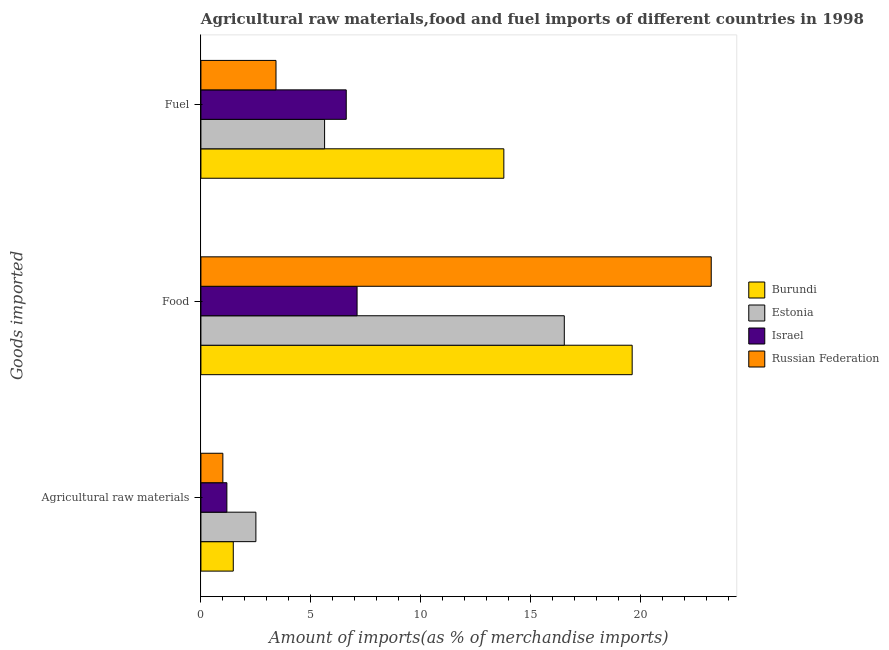How many different coloured bars are there?
Your response must be concise. 4. How many groups of bars are there?
Your response must be concise. 3. What is the label of the 3rd group of bars from the top?
Ensure brevity in your answer.  Agricultural raw materials. What is the percentage of food imports in Russian Federation?
Give a very brief answer. 23.2. Across all countries, what is the maximum percentage of food imports?
Provide a succinct answer. 23.2. Across all countries, what is the minimum percentage of food imports?
Provide a short and direct response. 7.1. In which country was the percentage of food imports maximum?
Offer a terse response. Russian Federation. In which country was the percentage of raw materials imports minimum?
Ensure brevity in your answer.  Russian Federation. What is the total percentage of fuel imports in the graph?
Your response must be concise. 29.41. What is the difference between the percentage of raw materials imports in Burundi and that in Estonia?
Your answer should be compact. -1.03. What is the difference between the percentage of raw materials imports in Israel and the percentage of food imports in Russian Federation?
Your answer should be compact. -22.02. What is the average percentage of fuel imports per country?
Make the answer very short. 7.35. What is the difference between the percentage of food imports and percentage of fuel imports in Russian Federation?
Keep it short and to the point. 19.78. What is the ratio of the percentage of fuel imports in Estonia to that in Russian Federation?
Your response must be concise. 1.65. Is the difference between the percentage of raw materials imports in Estonia and Russian Federation greater than the difference between the percentage of fuel imports in Estonia and Russian Federation?
Make the answer very short. No. What is the difference between the highest and the second highest percentage of raw materials imports?
Provide a succinct answer. 1.03. What is the difference between the highest and the lowest percentage of food imports?
Provide a succinct answer. 16.1. Is the sum of the percentage of food imports in Russian Federation and Burundi greater than the maximum percentage of raw materials imports across all countries?
Provide a succinct answer. Yes. What does the 4th bar from the top in Agricultural raw materials represents?
Ensure brevity in your answer.  Burundi. What does the 4th bar from the bottom in Agricultural raw materials represents?
Provide a short and direct response. Russian Federation. How many bars are there?
Provide a short and direct response. 12. What is the difference between two consecutive major ticks on the X-axis?
Your answer should be very brief. 5. Does the graph contain any zero values?
Offer a very short reply. No. How many legend labels are there?
Ensure brevity in your answer.  4. How are the legend labels stacked?
Provide a succinct answer. Vertical. What is the title of the graph?
Keep it short and to the point. Agricultural raw materials,food and fuel imports of different countries in 1998. Does "High income: OECD" appear as one of the legend labels in the graph?
Keep it short and to the point. No. What is the label or title of the X-axis?
Give a very brief answer. Amount of imports(as % of merchandise imports). What is the label or title of the Y-axis?
Make the answer very short. Goods imported. What is the Amount of imports(as % of merchandise imports) in Burundi in Agricultural raw materials?
Offer a very short reply. 1.47. What is the Amount of imports(as % of merchandise imports) of Estonia in Agricultural raw materials?
Offer a terse response. 2.5. What is the Amount of imports(as % of merchandise imports) of Israel in Agricultural raw materials?
Give a very brief answer. 1.18. What is the Amount of imports(as % of merchandise imports) in Russian Federation in Agricultural raw materials?
Keep it short and to the point. 1. What is the Amount of imports(as % of merchandise imports) of Burundi in Food?
Ensure brevity in your answer.  19.6. What is the Amount of imports(as % of merchandise imports) in Estonia in Food?
Provide a succinct answer. 16.52. What is the Amount of imports(as % of merchandise imports) of Israel in Food?
Your answer should be compact. 7.1. What is the Amount of imports(as % of merchandise imports) of Russian Federation in Food?
Offer a very short reply. 23.2. What is the Amount of imports(as % of merchandise imports) in Burundi in Fuel?
Make the answer very short. 13.77. What is the Amount of imports(as % of merchandise imports) of Estonia in Fuel?
Your answer should be very brief. 5.62. What is the Amount of imports(as % of merchandise imports) of Israel in Fuel?
Keep it short and to the point. 6.61. What is the Amount of imports(as % of merchandise imports) of Russian Federation in Fuel?
Provide a succinct answer. 3.41. Across all Goods imported, what is the maximum Amount of imports(as % of merchandise imports) of Burundi?
Make the answer very short. 19.6. Across all Goods imported, what is the maximum Amount of imports(as % of merchandise imports) of Estonia?
Your answer should be very brief. 16.52. Across all Goods imported, what is the maximum Amount of imports(as % of merchandise imports) of Israel?
Provide a succinct answer. 7.1. Across all Goods imported, what is the maximum Amount of imports(as % of merchandise imports) of Russian Federation?
Ensure brevity in your answer.  23.2. Across all Goods imported, what is the minimum Amount of imports(as % of merchandise imports) in Burundi?
Keep it short and to the point. 1.47. Across all Goods imported, what is the minimum Amount of imports(as % of merchandise imports) in Estonia?
Provide a short and direct response. 2.5. Across all Goods imported, what is the minimum Amount of imports(as % of merchandise imports) of Israel?
Keep it short and to the point. 1.18. Across all Goods imported, what is the minimum Amount of imports(as % of merchandise imports) in Russian Federation?
Your response must be concise. 1. What is the total Amount of imports(as % of merchandise imports) in Burundi in the graph?
Ensure brevity in your answer.  34.84. What is the total Amount of imports(as % of merchandise imports) in Estonia in the graph?
Provide a succinct answer. 24.64. What is the total Amount of imports(as % of merchandise imports) of Israel in the graph?
Offer a terse response. 14.88. What is the total Amount of imports(as % of merchandise imports) in Russian Federation in the graph?
Your response must be concise. 27.61. What is the difference between the Amount of imports(as % of merchandise imports) of Burundi in Agricultural raw materials and that in Food?
Your answer should be compact. -18.13. What is the difference between the Amount of imports(as % of merchandise imports) of Estonia in Agricultural raw materials and that in Food?
Give a very brief answer. -14.02. What is the difference between the Amount of imports(as % of merchandise imports) of Israel in Agricultural raw materials and that in Food?
Keep it short and to the point. -5.92. What is the difference between the Amount of imports(as % of merchandise imports) in Russian Federation in Agricultural raw materials and that in Food?
Your answer should be very brief. -22.2. What is the difference between the Amount of imports(as % of merchandise imports) of Burundi in Agricultural raw materials and that in Fuel?
Offer a terse response. -12.3. What is the difference between the Amount of imports(as % of merchandise imports) in Estonia in Agricultural raw materials and that in Fuel?
Provide a succinct answer. -3.12. What is the difference between the Amount of imports(as % of merchandise imports) in Israel in Agricultural raw materials and that in Fuel?
Provide a short and direct response. -5.43. What is the difference between the Amount of imports(as % of merchandise imports) of Russian Federation in Agricultural raw materials and that in Fuel?
Ensure brevity in your answer.  -2.42. What is the difference between the Amount of imports(as % of merchandise imports) of Burundi in Food and that in Fuel?
Provide a short and direct response. 5.83. What is the difference between the Amount of imports(as % of merchandise imports) of Estonia in Food and that in Fuel?
Your answer should be very brief. 10.9. What is the difference between the Amount of imports(as % of merchandise imports) of Israel in Food and that in Fuel?
Your response must be concise. 0.49. What is the difference between the Amount of imports(as % of merchandise imports) in Russian Federation in Food and that in Fuel?
Offer a very short reply. 19.78. What is the difference between the Amount of imports(as % of merchandise imports) of Burundi in Agricultural raw materials and the Amount of imports(as % of merchandise imports) of Estonia in Food?
Make the answer very short. -15.05. What is the difference between the Amount of imports(as % of merchandise imports) in Burundi in Agricultural raw materials and the Amount of imports(as % of merchandise imports) in Israel in Food?
Your response must be concise. -5.63. What is the difference between the Amount of imports(as % of merchandise imports) of Burundi in Agricultural raw materials and the Amount of imports(as % of merchandise imports) of Russian Federation in Food?
Your answer should be compact. -21.73. What is the difference between the Amount of imports(as % of merchandise imports) in Estonia in Agricultural raw materials and the Amount of imports(as % of merchandise imports) in Israel in Food?
Keep it short and to the point. -4.6. What is the difference between the Amount of imports(as % of merchandise imports) of Estonia in Agricultural raw materials and the Amount of imports(as % of merchandise imports) of Russian Federation in Food?
Your response must be concise. -20.7. What is the difference between the Amount of imports(as % of merchandise imports) of Israel in Agricultural raw materials and the Amount of imports(as % of merchandise imports) of Russian Federation in Food?
Offer a very short reply. -22.02. What is the difference between the Amount of imports(as % of merchandise imports) in Burundi in Agricultural raw materials and the Amount of imports(as % of merchandise imports) in Estonia in Fuel?
Make the answer very short. -4.15. What is the difference between the Amount of imports(as % of merchandise imports) of Burundi in Agricultural raw materials and the Amount of imports(as % of merchandise imports) of Israel in Fuel?
Your answer should be very brief. -5.14. What is the difference between the Amount of imports(as % of merchandise imports) of Burundi in Agricultural raw materials and the Amount of imports(as % of merchandise imports) of Russian Federation in Fuel?
Ensure brevity in your answer.  -1.94. What is the difference between the Amount of imports(as % of merchandise imports) of Estonia in Agricultural raw materials and the Amount of imports(as % of merchandise imports) of Israel in Fuel?
Give a very brief answer. -4.11. What is the difference between the Amount of imports(as % of merchandise imports) of Estonia in Agricultural raw materials and the Amount of imports(as % of merchandise imports) of Russian Federation in Fuel?
Your answer should be compact. -0.91. What is the difference between the Amount of imports(as % of merchandise imports) in Israel in Agricultural raw materials and the Amount of imports(as % of merchandise imports) in Russian Federation in Fuel?
Give a very brief answer. -2.23. What is the difference between the Amount of imports(as % of merchandise imports) of Burundi in Food and the Amount of imports(as % of merchandise imports) of Estonia in Fuel?
Offer a very short reply. 13.98. What is the difference between the Amount of imports(as % of merchandise imports) in Burundi in Food and the Amount of imports(as % of merchandise imports) in Israel in Fuel?
Keep it short and to the point. 13. What is the difference between the Amount of imports(as % of merchandise imports) in Burundi in Food and the Amount of imports(as % of merchandise imports) in Russian Federation in Fuel?
Provide a short and direct response. 16.19. What is the difference between the Amount of imports(as % of merchandise imports) in Estonia in Food and the Amount of imports(as % of merchandise imports) in Israel in Fuel?
Provide a short and direct response. 9.91. What is the difference between the Amount of imports(as % of merchandise imports) of Estonia in Food and the Amount of imports(as % of merchandise imports) of Russian Federation in Fuel?
Provide a succinct answer. 13.1. What is the difference between the Amount of imports(as % of merchandise imports) of Israel in Food and the Amount of imports(as % of merchandise imports) of Russian Federation in Fuel?
Your response must be concise. 3.69. What is the average Amount of imports(as % of merchandise imports) of Burundi per Goods imported?
Make the answer very short. 11.61. What is the average Amount of imports(as % of merchandise imports) of Estonia per Goods imported?
Provide a short and direct response. 8.21. What is the average Amount of imports(as % of merchandise imports) in Israel per Goods imported?
Make the answer very short. 4.96. What is the average Amount of imports(as % of merchandise imports) in Russian Federation per Goods imported?
Provide a short and direct response. 9.2. What is the difference between the Amount of imports(as % of merchandise imports) in Burundi and Amount of imports(as % of merchandise imports) in Estonia in Agricultural raw materials?
Provide a short and direct response. -1.03. What is the difference between the Amount of imports(as % of merchandise imports) in Burundi and Amount of imports(as % of merchandise imports) in Israel in Agricultural raw materials?
Give a very brief answer. 0.29. What is the difference between the Amount of imports(as % of merchandise imports) in Burundi and Amount of imports(as % of merchandise imports) in Russian Federation in Agricultural raw materials?
Offer a very short reply. 0.47. What is the difference between the Amount of imports(as % of merchandise imports) in Estonia and Amount of imports(as % of merchandise imports) in Israel in Agricultural raw materials?
Make the answer very short. 1.32. What is the difference between the Amount of imports(as % of merchandise imports) in Estonia and Amount of imports(as % of merchandise imports) in Russian Federation in Agricultural raw materials?
Provide a short and direct response. 1.5. What is the difference between the Amount of imports(as % of merchandise imports) of Israel and Amount of imports(as % of merchandise imports) of Russian Federation in Agricultural raw materials?
Give a very brief answer. 0.18. What is the difference between the Amount of imports(as % of merchandise imports) of Burundi and Amount of imports(as % of merchandise imports) of Estonia in Food?
Provide a succinct answer. 3.09. What is the difference between the Amount of imports(as % of merchandise imports) of Burundi and Amount of imports(as % of merchandise imports) of Israel in Food?
Offer a very short reply. 12.5. What is the difference between the Amount of imports(as % of merchandise imports) of Burundi and Amount of imports(as % of merchandise imports) of Russian Federation in Food?
Your response must be concise. -3.59. What is the difference between the Amount of imports(as % of merchandise imports) of Estonia and Amount of imports(as % of merchandise imports) of Israel in Food?
Ensure brevity in your answer.  9.42. What is the difference between the Amount of imports(as % of merchandise imports) in Estonia and Amount of imports(as % of merchandise imports) in Russian Federation in Food?
Your answer should be compact. -6.68. What is the difference between the Amount of imports(as % of merchandise imports) in Israel and Amount of imports(as % of merchandise imports) in Russian Federation in Food?
Your answer should be very brief. -16.1. What is the difference between the Amount of imports(as % of merchandise imports) of Burundi and Amount of imports(as % of merchandise imports) of Estonia in Fuel?
Make the answer very short. 8.15. What is the difference between the Amount of imports(as % of merchandise imports) in Burundi and Amount of imports(as % of merchandise imports) in Israel in Fuel?
Your answer should be compact. 7.16. What is the difference between the Amount of imports(as % of merchandise imports) of Burundi and Amount of imports(as % of merchandise imports) of Russian Federation in Fuel?
Your response must be concise. 10.36. What is the difference between the Amount of imports(as % of merchandise imports) of Estonia and Amount of imports(as % of merchandise imports) of Israel in Fuel?
Your answer should be very brief. -0.98. What is the difference between the Amount of imports(as % of merchandise imports) in Estonia and Amount of imports(as % of merchandise imports) in Russian Federation in Fuel?
Provide a succinct answer. 2.21. What is the difference between the Amount of imports(as % of merchandise imports) in Israel and Amount of imports(as % of merchandise imports) in Russian Federation in Fuel?
Make the answer very short. 3.19. What is the ratio of the Amount of imports(as % of merchandise imports) in Burundi in Agricultural raw materials to that in Food?
Your response must be concise. 0.07. What is the ratio of the Amount of imports(as % of merchandise imports) of Estonia in Agricultural raw materials to that in Food?
Give a very brief answer. 0.15. What is the ratio of the Amount of imports(as % of merchandise imports) in Israel in Agricultural raw materials to that in Food?
Your answer should be compact. 0.17. What is the ratio of the Amount of imports(as % of merchandise imports) of Russian Federation in Agricultural raw materials to that in Food?
Your response must be concise. 0.04. What is the ratio of the Amount of imports(as % of merchandise imports) in Burundi in Agricultural raw materials to that in Fuel?
Provide a succinct answer. 0.11. What is the ratio of the Amount of imports(as % of merchandise imports) of Estonia in Agricultural raw materials to that in Fuel?
Provide a succinct answer. 0.44. What is the ratio of the Amount of imports(as % of merchandise imports) of Israel in Agricultural raw materials to that in Fuel?
Keep it short and to the point. 0.18. What is the ratio of the Amount of imports(as % of merchandise imports) of Russian Federation in Agricultural raw materials to that in Fuel?
Ensure brevity in your answer.  0.29. What is the ratio of the Amount of imports(as % of merchandise imports) of Burundi in Food to that in Fuel?
Your answer should be very brief. 1.42. What is the ratio of the Amount of imports(as % of merchandise imports) in Estonia in Food to that in Fuel?
Your response must be concise. 2.94. What is the ratio of the Amount of imports(as % of merchandise imports) of Israel in Food to that in Fuel?
Give a very brief answer. 1.07. What is the ratio of the Amount of imports(as % of merchandise imports) of Russian Federation in Food to that in Fuel?
Your answer should be very brief. 6.8. What is the difference between the highest and the second highest Amount of imports(as % of merchandise imports) in Burundi?
Offer a terse response. 5.83. What is the difference between the highest and the second highest Amount of imports(as % of merchandise imports) of Estonia?
Provide a short and direct response. 10.9. What is the difference between the highest and the second highest Amount of imports(as % of merchandise imports) in Israel?
Give a very brief answer. 0.49. What is the difference between the highest and the second highest Amount of imports(as % of merchandise imports) in Russian Federation?
Give a very brief answer. 19.78. What is the difference between the highest and the lowest Amount of imports(as % of merchandise imports) of Burundi?
Keep it short and to the point. 18.13. What is the difference between the highest and the lowest Amount of imports(as % of merchandise imports) in Estonia?
Keep it short and to the point. 14.02. What is the difference between the highest and the lowest Amount of imports(as % of merchandise imports) of Israel?
Your answer should be very brief. 5.92. What is the difference between the highest and the lowest Amount of imports(as % of merchandise imports) of Russian Federation?
Ensure brevity in your answer.  22.2. 